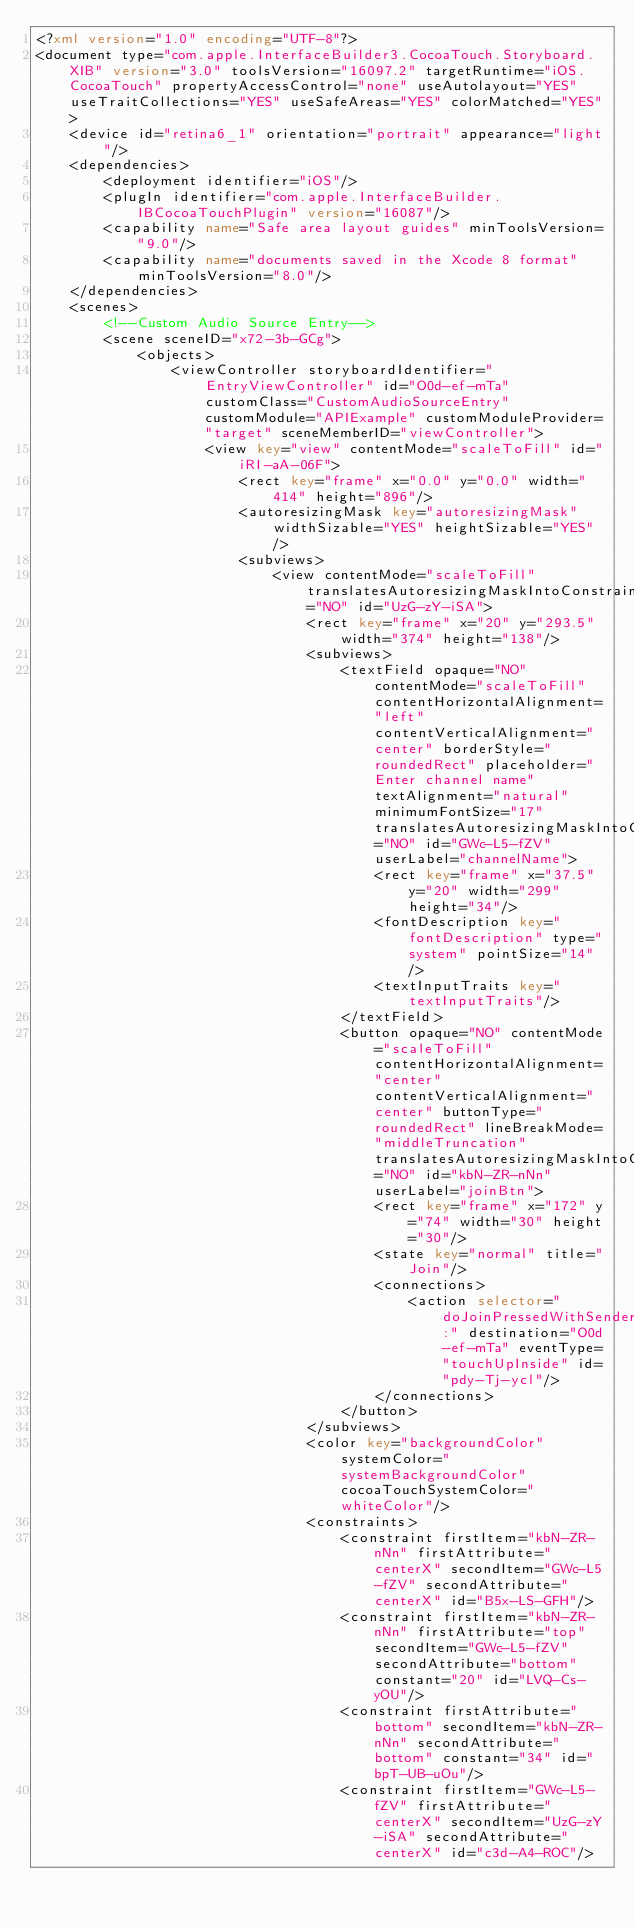Convert code to text. <code><loc_0><loc_0><loc_500><loc_500><_XML_><?xml version="1.0" encoding="UTF-8"?>
<document type="com.apple.InterfaceBuilder3.CocoaTouch.Storyboard.XIB" version="3.0" toolsVersion="16097.2" targetRuntime="iOS.CocoaTouch" propertyAccessControl="none" useAutolayout="YES" useTraitCollections="YES" useSafeAreas="YES" colorMatched="YES">
    <device id="retina6_1" orientation="portrait" appearance="light"/>
    <dependencies>
        <deployment identifier="iOS"/>
        <plugIn identifier="com.apple.InterfaceBuilder.IBCocoaTouchPlugin" version="16087"/>
        <capability name="Safe area layout guides" minToolsVersion="9.0"/>
        <capability name="documents saved in the Xcode 8 format" minToolsVersion="8.0"/>
    </dependencies>
    <scenes>
        <!--Custom Audio Source Entry-->
        <scene sceneID="x72-3b-GCg">
            <objects>
                <viewController storyboardIdentifier="EntryViewController" id="O0d-ef-mTa" customClass="CustomAudioSourceEntry" customModule="APIExample" customModuleProvider="target" sceneMemberID="viewController">
                    <view key="view" contentMode="scaleToFill" id="iRI-aA-06F">
                        <rect key="frame" x="0.0" y="0.0" width="414" height="896"/>
                        <autoresizingMask key="autoresizingMask" widthSizable="YES" heightSizable="YES"/>
                        <subviews>
                            <view contentMode="scaleToFill" translatesAutoresizingMaskIntoConstraints="NO" id="UzG-zY-iSA">
                                <rect key="frame" x="20" y="293.5" width="374" height="138"/>
                                <subviews>
                                    <textField opaque="NO" contentMode="scaleToFill" contentHorizontalAlignment="left" contentVerticalAlignment="center" borderStyle="roundedRect" placeholder="Enter channel name" textAlignment="natural" minimumFontSize="17" translatesAutoresizingMaskIntoConstraints="NO" id="GWc-L5-fZV" userLabel="channelName">
                                        <rect key="frame" x="37.5" y="20" width="299" height="34"/>
                                        <fontDescription key="fontDescription" type="system" pointSize="14"/>
                                        <textInputTraits key="textInputTraits"/>
                                    </textField>
                                    <button opaque="NO" contentMode="scaleToFill" contentHorizontalAlignment="center" contentVerticalAlignment="center" buttonType="roundedRect" lineBreakMode="middleTruncation" translatesAutoresizingMaskIntoConstraints="NO" id="kbN-ZR-nNn" userLabel="joinBtn">
                                        <rect key="frame" x="172" y="74" width="30" height="30"/>
                                        <state key="normal" title="Join"/>
                                        <connections>
                                            <action selector="doJoinPressedWithSender:" destination="O0d-ef-mTa" eventType="touchUpInside" id="pdy-Tj-ycl"/>
                                        </connections>
                                    </button>
                                </subviews>
                                <color key="backgroundColor" systemColor="systemBackgroundColor" cocoaTouchSystemColor="whiteColor"/>
                                <constraints>
                                    <constraint firstItem="kbN-ZR-nNn" firstAttribute="centerX" secondItem="GWc-L5-fZV" secondAttribute="centerX" id="B5x-LS-GFH"/>
                                    <constraint firstItem="kbN-ZR-nNn" firstAttribute="top" secondItem="GWc-L5-fZV" secondAttribute="bottom" constant="20" id="LVQ-Cs-yOU"/>
                                    <constraint firstAttribute="bottom" secondItem="kbN-ZR-nNn" secondAttribute="bottom" constant="34" id="bpT-UB-uOu"/>
                                    <constraint firstItem="GWc-L5-fZV" firstAttribute="centerX" secondItem="UzG-zY-iSA" secondAttribute="centerX" id="c3d-A4-ROC"/></code> 